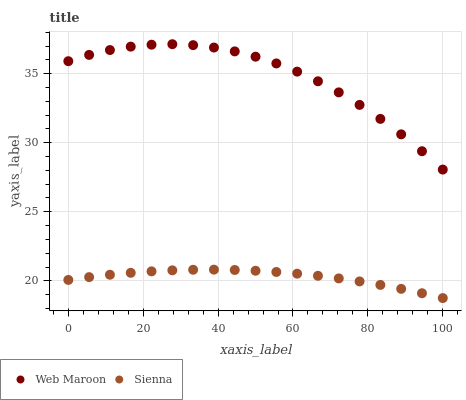Does Sienna have the minimum area under the curve?
Answer yes or no. Yes. Does Web Maroon have the maximum area under the curve?
Answer yes or no. Yes. Does Web Maroon have the minimum area under the curve?
Answer yes or no. No. Is Sienna the smoothest?
Answer yes or no. Yes. Is Web Maroon the roughest?
Answer yes or no. Yes. Is Web Maroon the smoothest?
Answer yes or no. No. Does Sienna have the lowest value?
Answer yes or no. Yes. Does Web Maroon have the lowest value?
Answer yes or no. No. Does Web Maroon have the highest value?
Answer yes or no. Yes. Is Sienna less than Web Maroon?
Answer yes or no. Yes. Is Web Maroon greater than Sienna?
Answer yes or no. Yes. Does Sienna intersect Web Maroon?
Answer yes or no. No. 